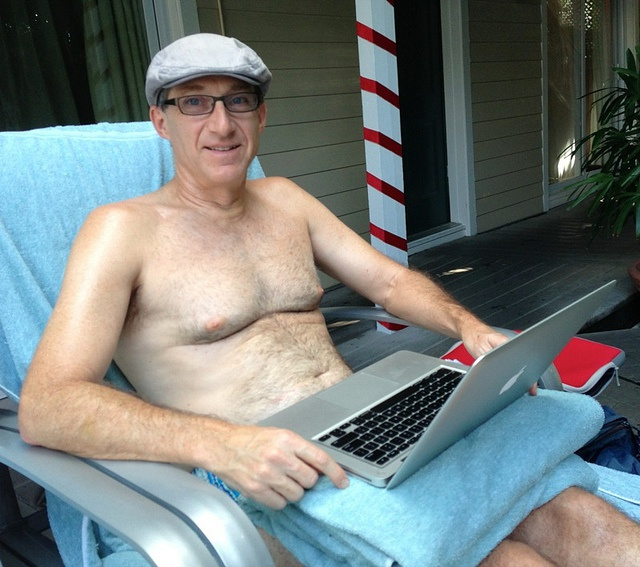Describe the objects in this image and their specific colors. I can see people in black, tan, lightgray, and darkgray tones, chair in black, lightblue, darkgray, and gray tones, laptop in black, darkgray, gray, and blue tones, potted plant in black, gray, and darkgreen tones, and backpack in black, navy, and blue tones in this image. 